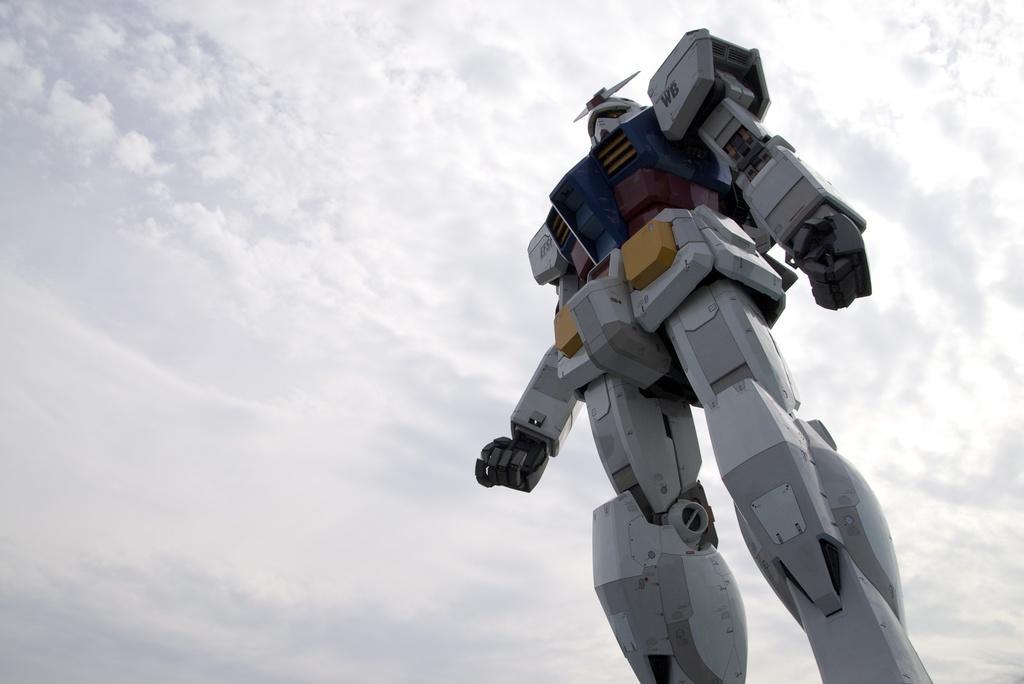How would you summarize this image in a sentence or two? In this image in the foreground there is one robot, and in the background there is sky. 